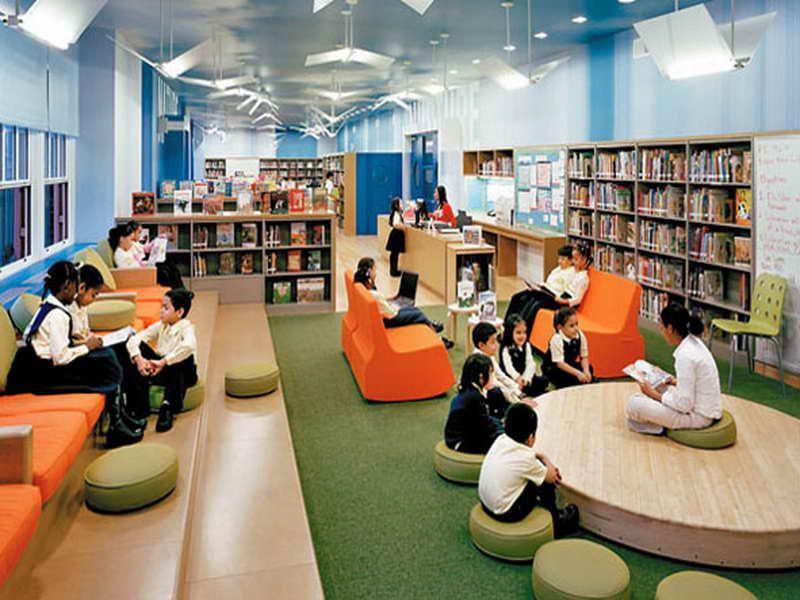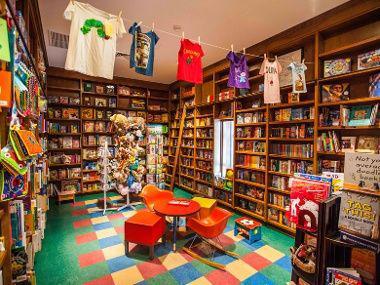The first image is the image on the left, the second image is the image on the right. Given the left and right images, does the statement "In one of the images, the people shop are sitting and reading." hold true? Answer yes or no. Yes. 